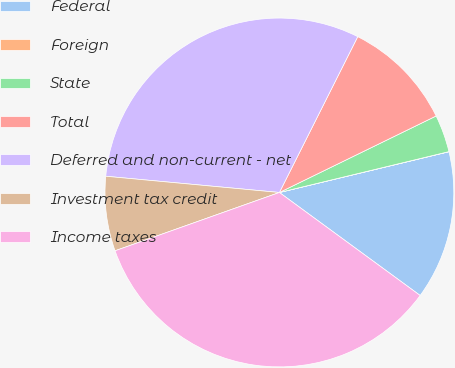Convert chart. <chart><loc_0><loc_0><loc_500><loc_500><pie_chart><fcel>Federal<fcel>Foreign<fcel>State<fcel>Total<fcel>Deferred and non-current - net<fcel>Investment tax credit<fcel>Income taxes<nl><fcel>13.81%<fcel>0.01%<fcel>3.46%<fcel>10.36%<fcel>30.93%<fcel>6.91%<fcel>34.52%<nl></chart> 